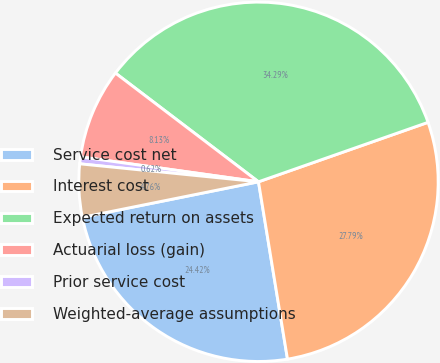<chart> <loc_0><loc_0><loc_500><loc_500><pie_chart><fcel>Service cost net<fcel>Interest cost<fcel>Expected return on assets<fcel>Actuarial loss (gain)<fcel>Prior service cost<fcel>Weighted-average assumptions<nl><fcel>24.42%<fcel>27.79%<fcel>34.29%<fcel>8.13%<fcel>0.62%<fcel>4.76%<nl></chart> 